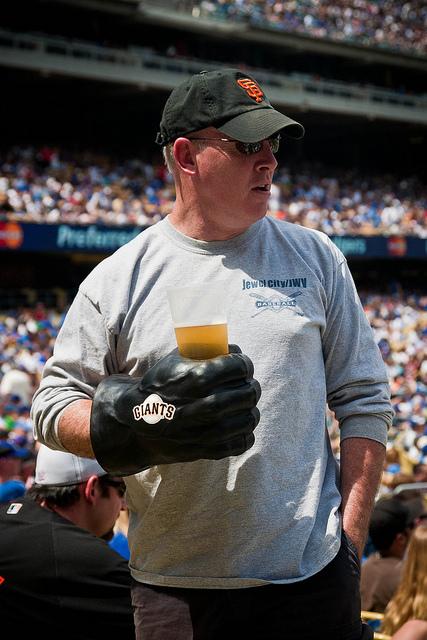What team's name is on the man's big black glove?
Concise answer only. Giants. What color is the man's shirt?
Give a very brief answer. Gray. What beverage is the man drinking?
Be succinct. Beer. 